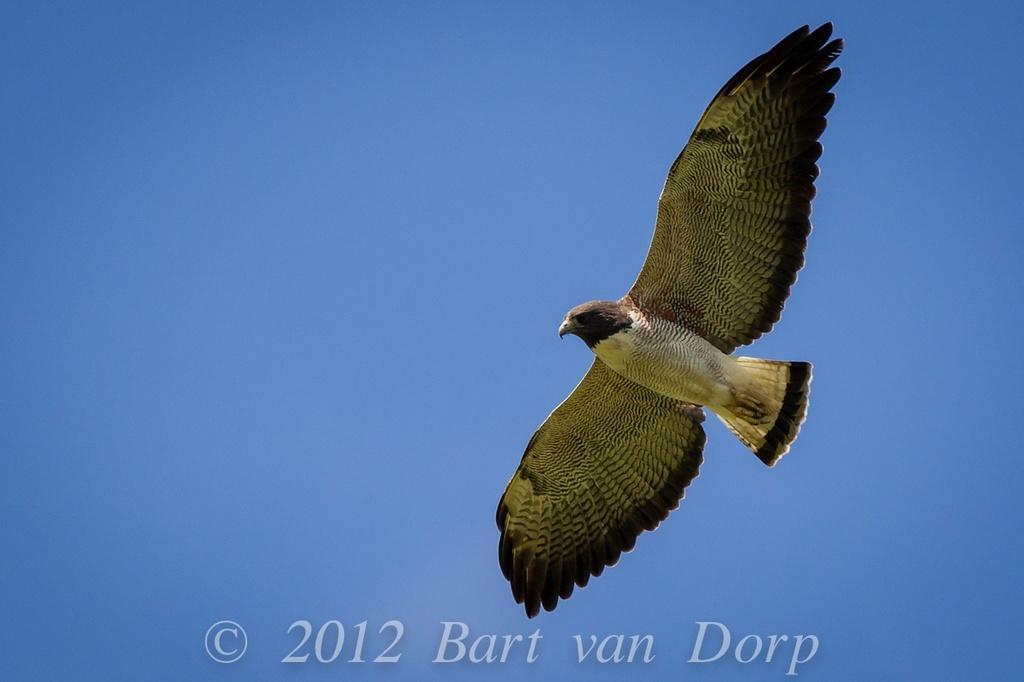Describe this image in one or two sentences. In this picture there is a bird flying. At the top there is sky. At the bottom there is text. 